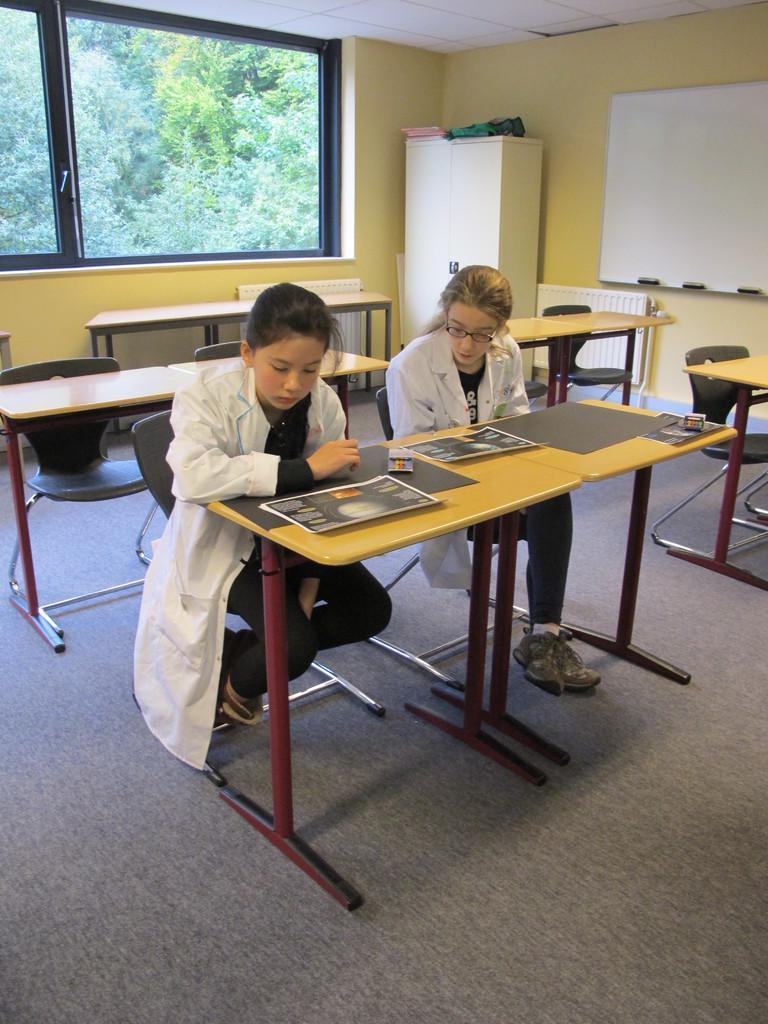Could you give a brief overview of what you see in this image? On the background we can see a wall in yellow colour, white colour cupboard and window. This is a ceiling. This is a floor. Here we can see chairs and tables. In Front of a picture we can see two girls on chairs in front of a table and observing posters which are on the table. 